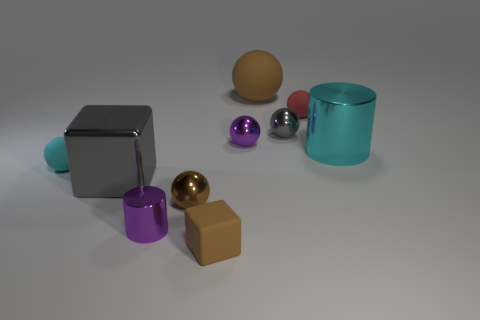Subtract all tiny purple metallic balls. How many balls are left? 5 Subtract all gray cylinders. How many brown balls are left? 2 Subtract all red spheres. How many spheres are left? 5 Subtract 2 spheres. How many spheres are left? 4 Subtract all purple spheres. Subtract all red blocks. How many spheres are left? 5 Subtract all cylinders. How many objects are left? 8 Add 5 small red matte balls. How many small red matte balls are left? 6 Add 4 small red rubber cylinders. How many small red rubber cylinders exist? 4 Subtract 0 green cubes. How many objects are left? 10 Subtract all large brown cubes. Subtract all gray blocks. How many objects are left? 9 